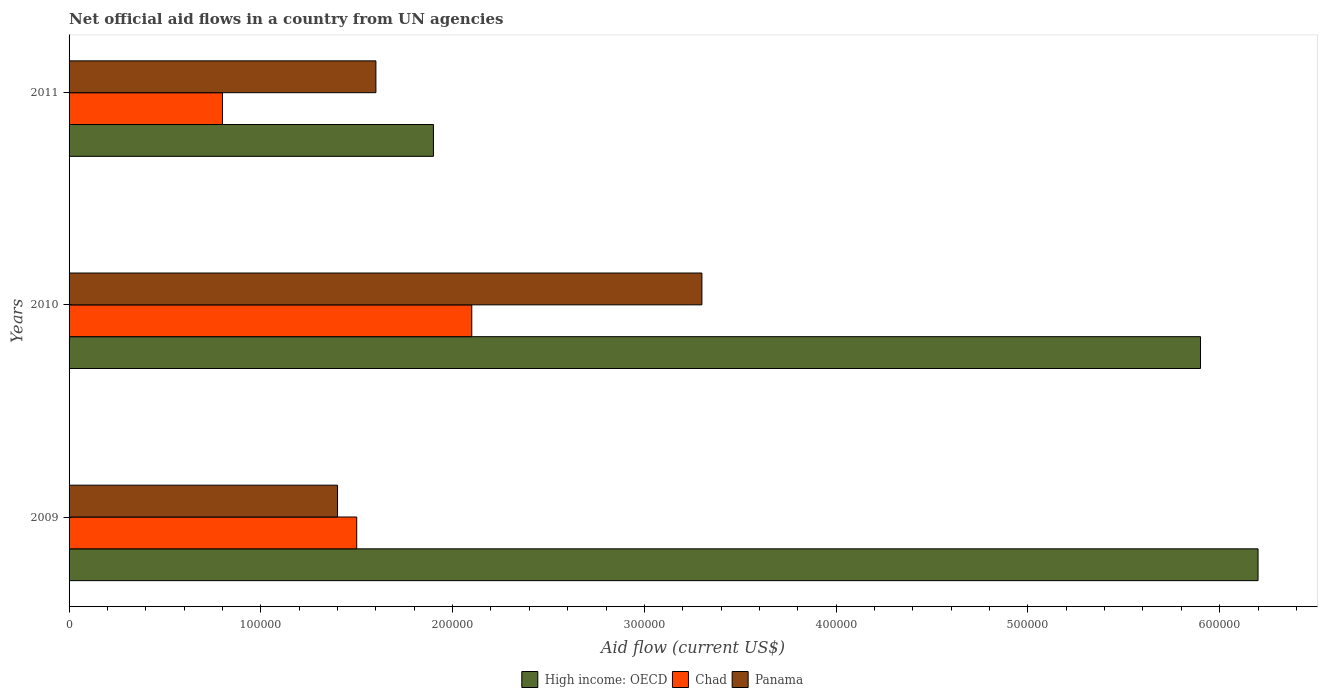How many different coloured bars are there?
Make the answer very short. 3. Are the number of bars on each tick of the Y-axis equal?
Keep it short and to the point. Yes. How many bars are there on the 2nd tick from the top?
Keep it short and to the point. 3. How many bars are there on the 3rd tick from the bottom?
Offer a terse response. 3. What is the net official aid flow in Chad in 2009?
Your answer should be very brief. 1.50e+05. Across all years, what is the maximum net official aid flow in Chad?
Make the answer very short. 2.10e+05. Across all years, what is the minimum net official aid flow in Panama?
Keep it short and to the point. 1.40e+05. In which year was the net official aid flow in Panama maximum?
Your answer should be very brief. 2010. What is the total net official aid flow in Panama in the graph?
Your answer should be very brief. 6.30e+05. What is the difference between the net official aid flow in Panama in 2010 and that in 2011?
Your answer should be compact. 1.70e+05. What is the difference between the net official aid flow in High income: OECD in 2009 and the net official aid flow in Chad in 2011?
Provide a short and direct response. 5.40e+05. What is the average net official aid flow in High income: OECD per year?
Your response must be concise. 4.67e+05. In the year 2011, what is the difference between the net official aid flow in Panama and net official aid flow in Chad?
Ensure brevity in your answer.  8.00e+04. In how many years, is the net official aid flow in Panama greater than 280000 US$?
Keep it short and to the point. 1. What is the ratio of the net official aid flow in Panama in 2009 to that in 2010?
Offer a very short reply. 0.42. Is the difference between the net official aid flow in Panama in 2009 and 2010 greater than the difference between the net official aid flow in Chad in 2009 and 2010?
Offer a terse response. No. What is the difference between the highest and the second highest net official aid flow in High income: OECD?
Make the answer very short. 3.00e+04. What is the difference between the highest and the lowest net official aid flow in Chad?
Your answer should be very brief. 1.30e+05. Is the sum of the net official aid flow in Panama in 2009 and 2010 greater than the maximum net official aid flow in High income: OECD across all years?
Make the answer very short. No. What does the 2nd bar from the top in 2010 represents?
Give a very brief answer. Chad. What does the 1st bar from the bottom in 2011 represents?
Your answer should be compact. High income: OECD. Is it the case that in every year, the sum of the net official aid flow in Chad and net official aid flow in High income: OECD is greater than the net official aid flow in Panama?
Your answer should be very brief. Yes. Are all the bars in the graph horizontal?
Your response must be concise. Yes. Are the values on the major ticks of X-axis written in scientific E-notation?
Give a very brief answer. No. Does the graph contain any zero values?
Your response must be concise. No. How many legend labels are there?
Your response must be concise. 3. How are the legend labels stacked?
Give a very brief answer. Horizontal. What is the title of the graph?
Offer a very short reply. Net official aid flows in a country from UN agencies. Does "Tanzania" appear as one of the legend labels in the graph?
Your answer should be compact. No. What is the label or title of the X-axis?
Make the answer very short. Aid flow (current US$). What is the Aid flow (current US$) of High income: OECD in 2009?
Make the answer very short. 6.20e+05. What is the Aid flow (current US$) of Panama in 2009?
Give a very brief answer. 1.40e+05. What is the Aid flow (current US$) of High income: OECD in 2010?
Provide a short and direct response. 5.90e+05. What is the Aid flow (current US$) in High income: OECD in 2011?
Keep it short and to the point. 1.90e+05. What is the Aid flow (current US$) of Chad in 2011?
Offer a very short reply. 8.00e+04. What is the Aid flow (current US$) of Panama in 2011?
Your response must be concise. 1.60e+05. Across all years, what is the maximum Aid flow (current US$) of High income: OECD?
Your response must be concise. 6.20e+05. Across all years, what is the maximum Aid flow (current US$) in Chad?
Your answer should be compact. 2.10e+05. Across all years, what is the minimum Aid flow (current US$) of High income: OECD?
Your answer should be very brief. 1.90e+05. Across all years, what is the minimum Aid flow (current US$) of Chad?
Provide a succinct answer. 8.00e+04. Across all years, what is the minimum Aid flow (current US$) in Panama?
Offer a very short reply. 1.40e+05. What is the total Aid flow (current US$) in High income: OECD in the graph?
Offer a very short reply. 1.40e+06. What is the total Aid flow (current US$) in Panama in the graph?
Provide a short and direct response. 6.30e+05. What is the difference between the Aid flow (current US$) in High income: OECD in 2009 and that in 2010?
Provide a succinct answer. 3.00e+04. What is the difference between the Aid flow (current US$) in High income: OECD in 2009 and the Aid flow (current US$) in Chad in 2010?
Your answer should be very brief. 4.10e+05. What is the difference between the Aid flow (current US$) of High income: OECD in 2009 and the Aid flow (current US$) of Chad in 2011?
Ensure brevity in your answer.  5.40e+05. What is the difference between the Aid flow (current US$) of Chad in 2009 and the Aid flow (current US$) of Panama in 2011?
Offer a very short reply. -10000. What is the difference between the Aid flow (current US$) of High income: OECD in 2010 and the Aid flow (current US$) of Chad in 2011?
Provide a short and direct response. 5.10e+05. What is the average Aid flow (current US$) of High income: OECD per year?
Ensure brevity in your answer.  4.67e+05. What is the average Aid flow (current US$) in Chad per year?
Your answer should be compact. 1.47e+05. In the year 2009, what is the difference between the Aid flow (current US$) in High income: OECD and Aid flow (current US$) in Chad?
Your answer should be very brief. 4.70e+05. In the year 2010, what is the difference between the Aid flow (current US$) of High income: OECD and Aid flow (current US$) of Chad?
Ensure brevity in your answer.  3.80e+05. In the year 2010, what is the difference between the Aid flow (current US$) of High income: OECD and Aid flow (current US$) of Panama?
Ensure brevity in your answer.  2.60e+05. In the year 2010, what is the difference between the Aid flow (current US$) in Chad and Aid flow (current US$) in Panama?
Keep it short and to the point. -1.20e+05. In the year 2011, what is the difference between the Aid flow (current US$) in High income: OECD and Aid flow (current US$) in Chad?
Your answer should be very brief. 1.10e+05. In the year 2011, what is the difference between the Aid flow (current US$) in High income: OECD and Aid flow (current US$) in Panama?
Your response must be concise. 3.00e+04. What is the ratio of the Aid flow (current US$) of High income: OECD in 2009 to that in 2010?
Offer a very short reply. 1.05. What is the ratio of the Aid flow (current US$) in Panama in 2009 to that in 2010?
Your answer should be very brief. 0.42. What is the ratio of the Aid flow (current US$) of High income: OECD in 2009 to that in 2011?
Give a very brief answer. 3.26. What is the ratio of the Aid flow (current US$) of Chad in 2009 to that in 2011?
Offer a terse response. 1.88. What is the ratio of the Aid flow (current US$) in High income: OECD in 2010 to that in 2011?
Offer a very short reply. 3.11. What is the ratio of the Aid flow (current US$) of Chad in 2010 to that in 2011?
Offer a terse response. 2.62. What is the ratio of the Aid flow (current US$) of Panama in 2010 to that in 2011?
Ensure brevity in your answer.  2.06. What is the difference between the highest and the second highest Aid flow (current US$) of High income: OECD?
Offer a terse response. 3.00e+04. What is the difference between the highest and the second highest Aid flow (current US$) in Chad?
Your answer should be very brief. 6.00e+04. 